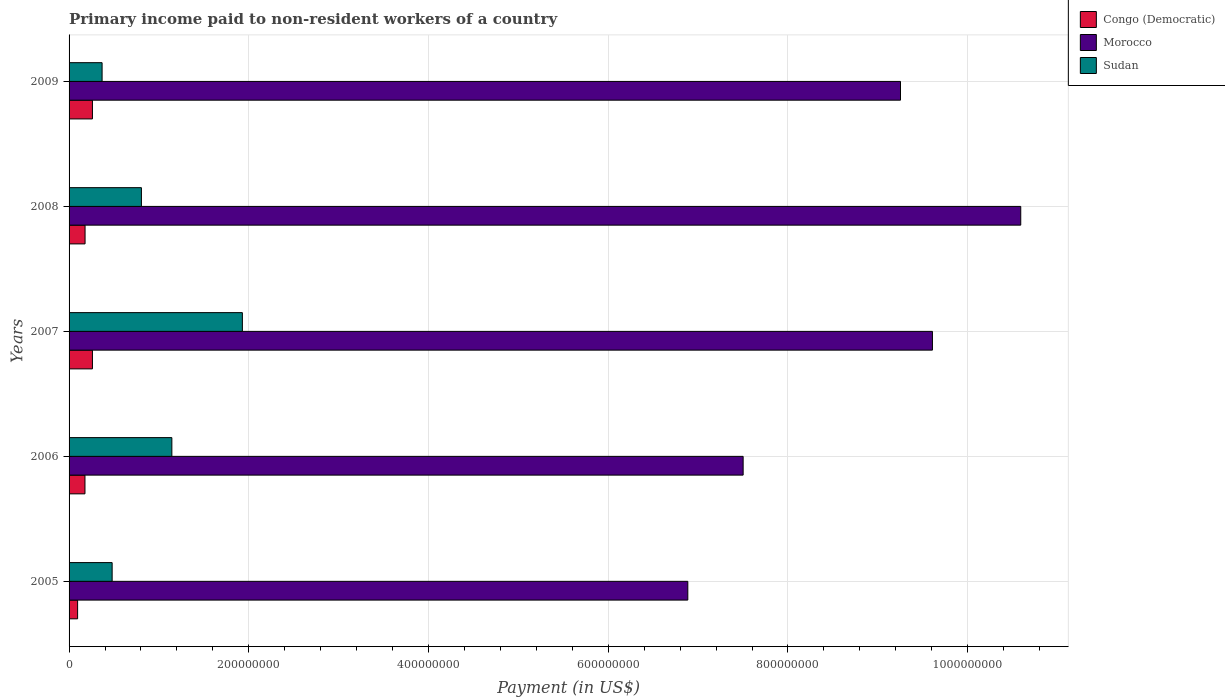Are the number of bars per tick equal to the number of legend labels?
Your response must be concise. Yes. Are the number of bars on each tick of the Y-axis equal?
Provide a short and direct response. Yes. How many bars are there on the 4th tick from the top?
Ensure brevity in your answer.  3. How many bars are there on the 3rd tick from the bottom?
Keep it short and to the point. 3. What is the amount paid to workers in Morocco in 2005?
Provide a succinct answer. 6.89e+08. Across all years, what is the maximum amount paid to workers in Morocco?
Your answer should be compact. 1.06e+09. Across all years, what is the minimum amount paid to workers in Sudan?
Provide a succinct answer. 3.67e+07. In which year was the amount paid to workers in Congo (Democratic) minimum?
Ensure brevity in your answer.  2005. What is the total amount paid to workers in Morocco in the graph?
Offer a very short reply. 4.38e+09. What is the difference between the amount paid to workers in Morocco in 2007 and that in 2009?
Ensure brevity in your answer.  3.55e+07. What is the difference between the amount paid to workers in Sudan in 2009 and the amount paid to workers in Morocco in 2007?
Give a very brief answer. -9.24e+08. What is the average amount paid to workers in Morocco per year?
Your answer should be compact. 8.77e+08. In the year 2007, what is the difference between the amount paid to workers in Congo (Democratic) and amount paid to workers in Sudan?
Your answer should be very brief. -1.67e+08. What is the ratio of the amount paid to workers in Morocco in 2006 to that in 2007?
Provide a succinct answer. 0.78. Is the difference between the amount paid to workers in Congo (Democratic) in 2008 and 2009 greater than the difference between the amount paid to workers in Sudan in 2008 and 2009?
Provide a short and direct response. No. What is the difference between the highest and the second highest amount paid to workers in Sudan?
Provide a short and direct response. 7.85e+07. What is the difference between the highest and the lowest amount paid to workers in Morocco?
Keep it short and to the point. 3.71e+08. In how many years, is the amount paid to workers in Congo (Democratic) greater than the average amount paid to workers in Congo (Democratic) taken over all years?
Your answer should be compact. 2. What does the 1st bar from the top in 2008 represents?
Provide a short and direct response. Sudan. What does the 3rd bar from the bottom in 2006 represents?
Provide a succinct answer. Sudan. Is it the case that in every year, the sum of the amount paid to workers in Sudan and amount paid to workers in Congo (Democratic) is greater than the amount paid to workers in Morocco?
Make the answer very short. No. Are the values on the major ticks of X-axis written in scientific E-notation?
Provide a short and direct response. No. Does the graph contain any zero values?
Keep it short and to the point. No. Does the graph contain grids?
Offer a very short reply. Yes. Where does the legend appear in the graph?
Give a very brief answer. Top right. How many legend labels are there?
Offer a terse response. 3. What is the title of the graph?
Offer a terse response. Primary income paid to non-resident workers of a country. What is the label or title of the X-axis?
Provide a short and direct response. Payment (in US$). What is the Payment (in US$) of Congo (Democratic) in 2005?
Your answer should be very brief. 9.50e+06. What is the Payment (in US$) of Morocco in 2005?
Ensure brevity in your answer.  6.89e+08. What is the Payment (in US$) of Sudan in 2005?
Keep it short and to the point. 4.79e+07. What is the Payment (in US$) of Congo (Democratic) in 2006?
Offer a very short reply. 1.77e+07. What is the Payment (in US$) in Morocco in 2006?
Offer a terse response. 7.50e+08. What is the Payment (in US$) in Sudan in 2006?
Offer a very short reply. 1.14e+08. What is the Payment (in US$) of Congo (Democratic) in 2007?
Ensure brevity in your answer.  2.60e+07. What is the Payment (in US$) of Morocco in 2007?
Keep it short and to the point. 9.61e+08. What is the Payment (in US$) of Sudan in 2007?
Make the answer very short. 1.93e+08. What is the Payment (in US$) in Congo (Democratic) in 2008?
Provide a succinct answer. 1.78e+07. What is the Payment (in US$) in Morocco in 2008?
Give a very brief answer. 1.06e+09. What is the Payment (in US$) of Sudan in 2008?
Give a very brief answer. 8.05e+07. What is the Payment (in US$) of Congo (Democratic) in 2009?
Keep it short and to the point. 2.60e+07. What is the Payment (in US$) in Morocco in 2009?
Give a very brief answer. 9.25e+08. What is the Payment (in US$) of Sudan in 2009?
Give a very brief answer. 3.67e+07. Across all years, what is the maximum Payment (in US$) of Congo (Democratic)?
Make the answer very short. 2.60e+07. Across all years, what is the maximum Payment (in US$) of Morocco?
Provide a short and direct response. 1.06e+09. Across all years, what is the maximum Payment (in US$) of Sudan?
Give a very brief answer. 1.93e+08. Across all years, what is the minimum Payment (in US$) in Congo (Democratic)?
Keep it short and to the point. 9.50e+06. Across all years, what is the minimum Payment (in US$) of Morocco?
Your answer should be compact. 6.89e+08. Across all years, what is the minimum Payment (in US$) in Sudan?
Your answer should be very brief. 3.67e+07. What is the total Payment (in US$) in Congo (Democratic) in the graph?
Your answer should be very brief. 9.70e+07. What is the total Payment (in US$) of Morocco in the graph?
Keep it short and to the point. 4.38e+09. What is the total Payment (in US$) of Sudan in the graph?
Offer a very short reply. 4.72e+08. What is the difference between the Payment (in US$) in Congo (Democratic) in 2005 and that in 2006?
Offer a terse response. -8.20e+06. What is the difference between the Payment (in US$) of Morocco in 2005 and that in 2006?
Keep it short and to the point. -6.16e+07. What is the difference between the Payment (in US$) in Sudan in 2005 and that in 2006?
Make the answer very short. -6.65e+07. What is the difference between the Payment (in US$) of Congo (Democratic) in 2005 and that in 2007?
Make the answer very short. -1.65e+07. What is the difference between the Payment (in US$) in Morocco in 2005 and that in 2007?
Your answer should be very brief. -2.72e+08. What is the difference between the Payment (in US$) of Sudan in 2005 and that in 2007?
Give a very brief answer. -1.45e+08. What is the difference between the Payment (in US$) of Congo (Democratic) in 2005 and that in 2008?
Offer a very short reply. -8.30e+06. What is the difference between the Payment (in US$) in Morocco in 2005 and that in 2008?
Keep it short and to the point. -3.71e+08. What is the difference between the Payment (in US$) in Sudan in 2005 and that in 2008?
Ensure brevity in your answer.  -3.26e+07. What is the difference between the Payment (in US$) of Congo (Democratic) in 2005 and that in 2009?
Offer a very short reply. -1.65e+07. What is the difference between the Payment (in US$) in Morocco in 2005 and that in 2009?
Your response must be concise. -2.37e+08. What is the difference between the Payment (in US$) in Sudan in 2005 and that in 2009?
Offer a terse response. 1.12e+07. What is the difference between the Payment (in US$) in Congo (Democratic) in 2006 and that in 2007?
Provide a short and direct response. -8.30e+06. What is the difference between the Payment (in US$) in Morocco in 2006 and that in 2007?
Give a very brief answer. -2.11e+08. What is the difference between the Payment (in US$) of Sudan in 2006 and that in 2007?
Your response must be concise. -7.85e+07. What is the difference between the Payment (in US$) in Morocco in 2006 and that in 2008?
Provide a succinct answer. -3.09e+08. What is the difference between the Payment (in US$) of Sudan in 2006 and that in 2008?
Provide a succinct answer. 3.39e+07. What is the difference between the Payment (in US$) in Congo (Democratic) in 2006 and that in 2009?
Your response must be concise. -8.30e+06. What is the difference between the Payment (in US$) of Morocco in 2006 and that in 2009?
Your response must be concise. -1.75e+08. What is the difference between the Payment (in US$) in Sudan in 2006 and that in 2009?
Make the answer very short. 7.76e+07. What is the difference between the Payment (in US$) in Congo (Democratic) in 2007 and that in 2008?
Keep it short and to the point. 8.20e+06. What is the difference between the Payment (in US$) in Morocco in 2007 and that in 2008?
Ensure brevity in your answer.  -9.83e+07. What is the difference between the Payment (in US$) of Sudan in 2007 and that in 2008?
Ensure brevity in your answer.  1.12e+08. What is the difference between the Payment (in US$) in Morocco in 2007 and that in 2009?
Offer a very short reply. 3.55e+07. What is the difference between the Payment (in US$) of Sudan in 2007 and that in 2009?
Your response must be concise. 1.56e+08. What is the difference between the Payment (in US$) in Congo (Democratic) in 2008 and that in 2009?
Keep it short and to the point. -8.20e+06. What is the difference between the Payment (in US$) in Morocco in 2008 and that in 2009?
Your answer should be very brief. 1.34e+08. What is the difference between the Payment (in US$) of Sudan in 2008 and that in 2009?
Offer a terse response. 4.38e+07. What is the difference between the Payment (in US$) in Congo (Democratic) in 2005 and the Payment (in US$) in Morocco in 2006?
Make the answer very short. -7.41e+08. What is the difference between the Payment (in US$) in Congo (Democratic) in 2005 and the Payment (in US$) in Sudan in 2006?
Offer a terse response. -1.05e+08. What is the difference between the Payment (in US$) of Morocco in 2005 and the Payment (in US$) of Sudan in 2006?
Ensure brevity in your answer.  5.74e+08. What is the difference between the Payment (in US$) in Congo (Democratic) in 2005 and the Payment (in US$) in Morocco in 2007?
Your answer should be compact. -9.51e+08. What is the difference between the Payment (in US$) of Congo (Democratic) in 2005 and the Payment (in US$) of Sudan in 2007?
Provide a short and direct response. -1.83e+08. What is the difference between the Payment (in US$) in Morocco in 2005 and the Payment (in US$) in Sudan in 2007?
Provide a succinct answer. 4.96e+08. What is the difference between the Payment (in US$) of Congo (Democratic) in 2005 and the Payment (in US$) of Morocco in 2008?
Give a very brief answer. -1.05e+09. What is the difference between the Payment (in US$) of Congo (Democratic) in 2005 and the Payment (in US$) of Sudan in 2008?
Give a very brief answer. -7.10e+07. What is the difference between the Payment (in US$) of Morocco in 2005 and the Payment (in US$) of Sudan in 2008?
Keep it short and to the point. 6.08e+08. What is the difference between the Payment (in US$) of Congo (Democratic) in 2005 and the Payment (in US$) of Morocco in 2009?
Your answer should be compact. -9.16e+08. What is the difference between the Payment (in US$) in Congo (Democratic) in 2005 and the Payment (in US$) in Sudan in 2009?
Your answer should be very brief. -2.72e+07. What is the difference between the Payment (in US$) in Morocco in 2005 and the Payment (in US$) in Sudan in 2009?
Provide a short and direct response. 6.52e+08. What is the difference between the Payment (in US$) of Congo (Democratic) in 2006 and the Payment (in US$) of Morocco in 2007?
Give a very brief answer. -9.43e+08. What is the difference between the Payment (in US$) of Congo (Democratic) in 2006 and the Payment (in US$) of Sudan in 2007?
Provide a succinct answer. -1.75e+08. What is the difference between the Payment (in US$) in Morocco in 2006 and the Payment (in US$) in Sudan in 2007?
Offer a terse response. 5.57e+08. What is the difference between the Payment (in US$) in Congo (Democratic) in 2006 and the Payment (in US$) in Morocco in 2008?
Keep it short and to the point. -1.04e+09. What is the difference between the Payment (in US$) of Congo (Democratic) in 2006 and the Payment (in US$) of Sudan in 2008?
Ensure brevity in your answer.  -6.28e+07. What is the difference between the Payment (in US$) of Morocco in 2006 and the Payment (in US$) of Sudan in 2008?
Make the answer very short. 6.70e+08. What is the difference between the Payment (in US$) of Congo (Democratic) in 2006 and the Payment (in US$) of Morocco in 2009?
Your answer should be compact. -9.08e+08. What is the difference between the Payment (in US$) of Congo (Democratic) in 2006 and the Payment (in US$) of Sudan in 2009?
Ensure brevity in your answer.  -1.90e+07. What is the difference between the Payment (in US$) in Morocco in 2006 and the Payment (in US$) in Sudan in 2009?
Provide a short and direct response. 7.13e+08. What is the difference between the Payment (in US$) of Congo (Democratic) in 2007 and the Payment (in US$) of Morocco in 2008?
Provide a short and direct response. -1.03e+09. What is the difference between the Payment (in US$) of Congo (Democratic) in 2007 and the Payment (in US$) of Sudan in 2008?
Offer a terse response. -5.45e+07. What is the difference between the Payment (in US$) of Morocco in 2007 and the Payment (in US$) of Sudan in 2008?
Make the answer very short. 8.80e+08. What is the difference between the Payment (in US$) in Congo (Democratic) in 2007 and the Payment (in US$) in Morocco in 2009?
Your answer should be compact. -8.99e+08. What is the difference between the Payment (in US$) in Congo (Democratic) in 2007 and the Payment (in US$) in Sudan in 2009?
Make the answer very short. -1.07e+07. What is the difference between the Payment (in US$) in Morocco in 2007 and the Payment (in US$) in Sudan in 2009?
Make the answer very short. 9.24e+08. What is the difference between the Payment (in US$) of Congo (Democratic) in 2008 and the Payment (in US$) of Morocco in 2009?
Make the answer very short. -9.07e+08. What is the difference between the Payment (in US$) in Congo (Democratic) in 2008 and the Payment (in US$) in Sudan in 2009?
Your response must be concise. -1.89e+07. What is the difference between the Payment (in US$) in Morocco in 2008 and the Payment (in US$) in Sudan in 2009?
Give a very brief answer. 1.02e+09. What is the average Payment (in US$) of Congo (Democratic) per year?
Ensure brevity in your answer.  1.94e+07. What is the average Payment (in US$) in Morocco per year?
Your answer should be compact. 8.77e+08. What is the average Payment (in US$) in Sudan per year?
Keep it short and to the point. 9.45e+07. In the year 2005, what is the difference between the Payment (in US$) of Congo (Democratic) and Payment (in US$) of Morocco?
Make the answer very short. -6.79e+08. In the year 2005, what is the difference between the Payment (in US$) of Congo (Democratic) and Payment (in US$) of Sudan?
Ensure brevity in your answer.  -3.84e+07. In the year 2005, what is the difference between the Payment (in US$) in Morocco and Payment (in US$) in Sudan?
Give a very brief answer. 6.41e+08. In the year 2006, what is the difference between the Payment (in US$) in Congo (Democratic) and Payment (in US$) in Morocco?
Make the answer very short. -7.32e+08. In the year 2006, what is the difference between the Payment (in US$) of Congo (Democratic) and Payment (in US$) of Sudan?
Offer a terse response. -9.67e+07. In the year 2006, what is the difference between the Payment (in US$) of Morocco and Payment (in US$) of Sudan?
Provide a succinct answer. 6.36e+08. In the year 2007, what is the difference between the Payment (in US$) in Congo (Democratic) and Payment (in US$) in Morocco?
Ensure brevity in your answer.  -9.35e+08. In the year 2007, what is the difference between the Payment (in US$) in Congo (Democratic) and Payment (in US$) in Sudan?
Offer a terse response. -1.67e+08. In the year 2007, what is the difference between the Payment (in US$) of Morocco and Payment (in US$) of Sudan?
Your response must be concise. 7.68e+08. In the year 2008, what is the difference between the Payment (in US$) in Congo (Democratic) and Payment (in US$) in Morocco?
Ensure brevity in your answer.  -1.04e+09. In the year 2008, what is the difference between the Payment (in US$) of Congo (Democratic) and Payment (in US$) of Sudan?
Provide a succinct answer. -6.27e+07. In the year 2008, what is the difference between the Payment (in US$) in Morocco and Payment (in US$) in Sudan?
Make the answer very short. 9.79e+08. In the year 2009, what is the difference between the Payment (in US$) of Congo (Democratic) and Payment (in US$) of Morocco?
Provide a short and direct response. -8.99e+08. In the year 2009, what is the difference between the Payment (in US$) in Congo (Democratic) and Payment (in US$) in Sudan?
Your response must be concise. -1.07e+07. In the year 2009, what is the difference between the Payment (in US$) in Morocco and Payment (in US$) in Sudan?
Keep it short and to the point. 8.89e+08. What is the ratio of the Payment (in US$) of Congo (Democratic) in 2005 to that in 2006?
Offer a very short reply. 0.54. What is the ratio of the Payment (in US$) of Morocco in 2005 to that in 2006?
Ensure brevity in your answer.  0.92. What is the ratio of the Payment (in US$) in Sudan in 2005 to that in 2006?
Give a very brief answer. 0.42. What is the ratio of the Payment (in US$) of Congo (Democratic) in 2005 to that in 2007?
Your answer should be very brief. 0.37. What is the ratio of the Payment (in US$) of Morocco in 2005 to that in 2007?
Your response must be concise. 0.72. What is the ratio of the Payment (in US$) of Sudan in 2005 to that in 2007?
Provide a succinct answer. 0.25. What is the ratio of the Payment (in US$) of Congo (Democratic) in 2005 to that in 2008?
Make the answer very short. 0.53. What is the ratio of the Payment (in US$) in Morocco in 2005 to that in 2008?
Make the answer very short. 0.65. What is the ratio of the Payment (in US$) in Sudan in 2005 to that in 2008?
Make the answer very short. 0.6. What is the ratio of the Payment (in US$) of Congo (Democratic) in 2005 to that in 2009?
Provide a short and direct response. 0.37. What is the ratio of the Payment (in US$) in Morocco in 2005 to that in 2009?
Keep it short and to the point. 0.74. What is the ratio of the Payment (in US$) in Sudan in 2005 to that in 2009?
Your answer should be compact. 1.3. What is the ratio of the Payment (in US$) of Congo (Democratic) in 2006 to that in 2007?
Your answer should be very brief. 0.68. What is the ratio of the Payment (in US$) of Morocco in 2006 to that in 2007?
Offer a very short reply. 0.78. What is the ratio of the Payment (in US$) of Sudan in 2006 to that in 2007?
Your answer should be compact. 0.59. What is the ratio of the Payment (in US$) of Morocco in 2006 to that in 2008?
Provide a short and direct response. 0.71. What is the ratio of the Payment (in US$) in Sudan in 2006 to that in 2008?
Make the answer very short. 1.42. What is the ratio of the Payment (in US$) in Congo (Democratic) in 2006 to that in 2009?
Your answer should be very brief. 0.68. What is the ratio of the Payment (in US$) in Morocco in 2006 to that in 2009?
Provide a short and direct response. 0.81. What is the ratio of the Payment (in US$) of Sudan in 2006 to that in 2009?
Your answer should be compact. 3.11. What is the ratio of the Payment (in US$) of Congo (Democratic) in 2007 to that in 2008?
Ensure brevity in your answer.  1.46. What is the ratio of the Payment (in US$) in Morocco in 2007 to that in 2008?
Make the answer very short. 0.91. What is the ratio of the Payment (in US$) of Sudan in 2007 to that in 2008?
Your answer should be very brief. 2.4. What is the ratio of the Payment (in US$) in Congo (Democratic) in 2007 to that in 2009?
Your answer should be compact. 1. What is the ratio of the Payment (in US$) of Morocco in 2007 to that in 2009?
Provide a short and direct response. 1.04. What is the ratio of the Payment (in US$) of Sudan in 2007 to that in 2009?
Ensure brevity in your answer.  5.25. What is the ratio of the Payment (in US$) in Congo (Democratic) in 2008 to that in 2009?
Give a very brief answer. 0.68. What is the ratio of the Payment (in US$) in Morocco in 2008 to that in 2009?
Provide a short and direct response. 1.14. What is the ratio of the Payment (in US$) of Sudan in 2008 to that in 2009?
Provide a short and direct response. 2.19. What is the difference between the highest and the second highest Payment (in US$) of Congo (Democratic)?
Keep it short and to the point. 0. What is the difference between the highest and the second highest Payment (in US$) of Morocco?
Keep it short and to the point. 9.83e+07. What is the difference between the highest and the second highest Payment (in US$) of Sudan?
Your response must be concise. 7.85e+07. What is the difference between the highest and the lowest Payment (in US$) of Congo (Democratic)?
Provide a succinct answer. 1.65e+07. What is the difference between the highest and the lowest Payment (in US$) in Morocco?
Ensure brevity in your answer.  3.71e+08. What is the difference between the highest and the lowest Payment (in US$) in Sudan?
Your answer should be very brief. 1.56e+08. 